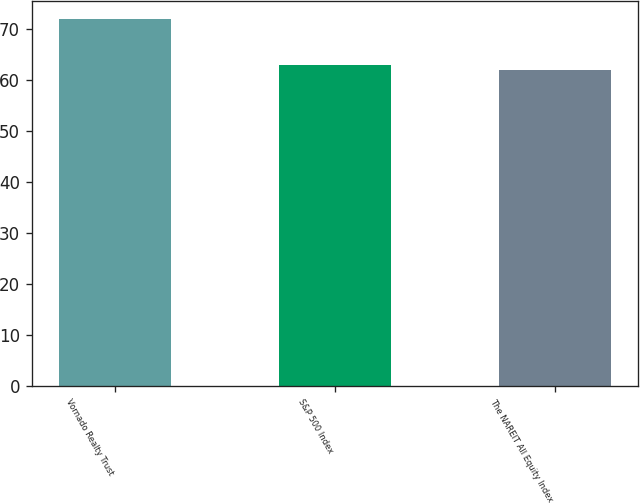<chart> <loc_0><loc_0><loc_500><loc_500><bar_chart><fcel>Vornado Realty Trust<fcel>S&P 500 Index<fcel>The NAREIT All Equity Index<nl><fcel>72<fcel>63<fcel>62<nl></chart> 